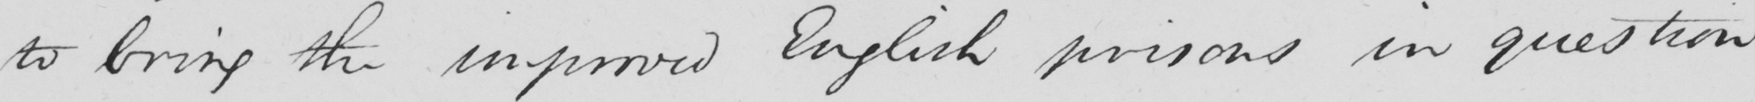Transcribe the text shown in this historical manuscript line. to bring the improved English prisons in question 